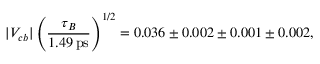<formula> <loc_0><loc_0><loc_500><loc_500>| V _ { c b } | \left ( \frac { \tau _ { B } } { 1 . 4 9 \, p s } \right ) ^ { 1 / 2 } = 0 . 0 3 6 \pm 0 . 0 0 2 \pm 0 . 0 0 1 \pm 0 . 0 0 2 ,</formula> 